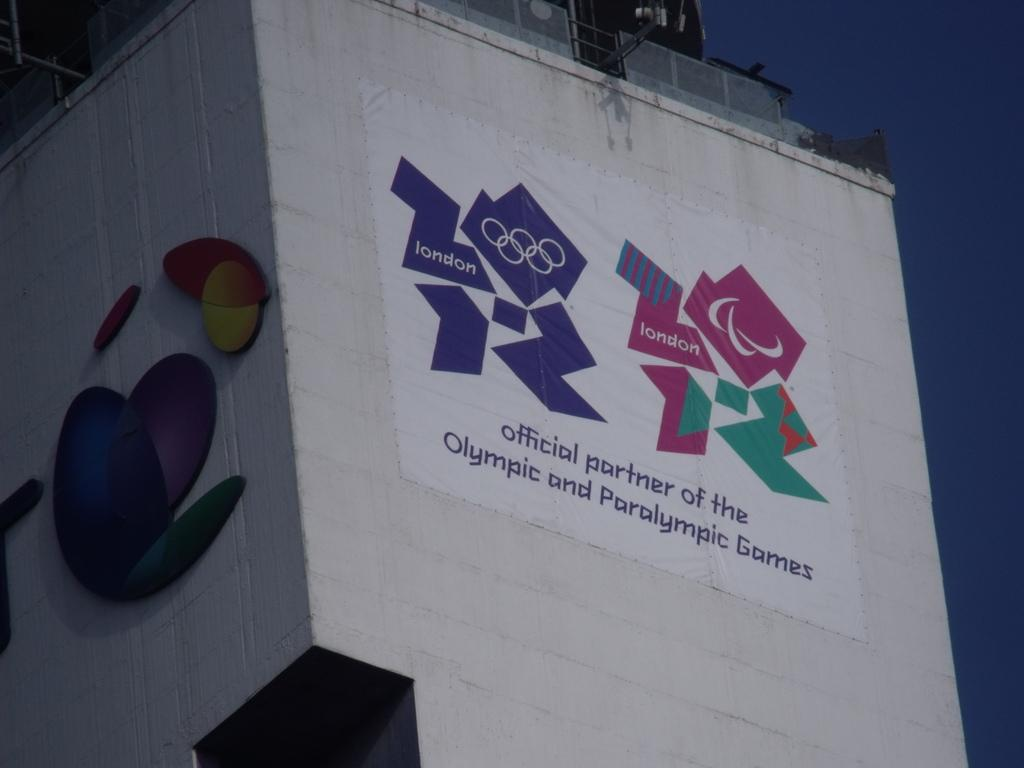What is the main structure visible in the image? There is a building in the image. Is there anything attached to the building? Yes, there is a banner attached to the building. What type of wilderness can be seen in the image? There is no wilderness present in the image; it features a building with a banner attached to it. How many times is the ball kicked in the image? There is no ball or kicking activity present in the image. 